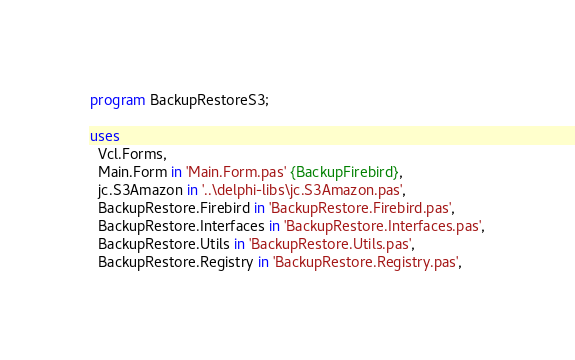Convert code to text. <code><loc_0><loc_0><loc_500><loc_500><_Pascal_>program BackupRestoreS3;

uses
  Vcl.Forms,
  Main.Form in 'Main.Form.pas' {BackupFirebird},
  jc.S3Amazon in '..\delphi-libs\jc.S3Amazon.pas',
  BackupRestore.Firebird in 'BackupRestore.Firebird.pas',
  BackupRestore.Interfaces in 'BackupRestore.Interfaces.pas',
  BackupRestore.Utils in 'BackupRestore.Utils.pas',
  BackupRestore.Registry in 'BackupRestore.Registry.pas',</code> 